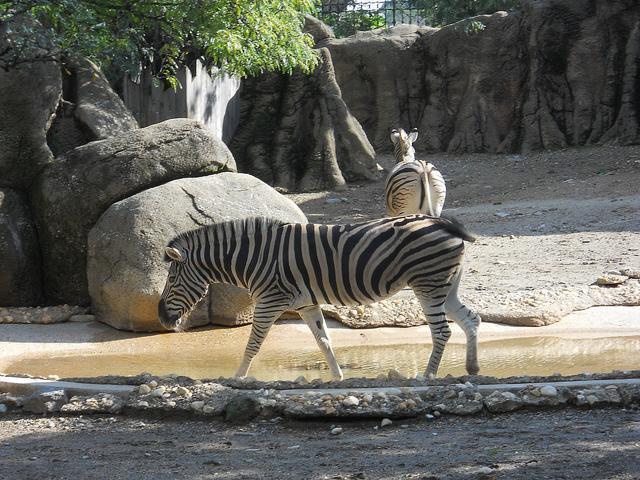How many zebras are there?
Give a very brief answer. 2. How many people are walking across the road?
Give a very brief answer. 0. 